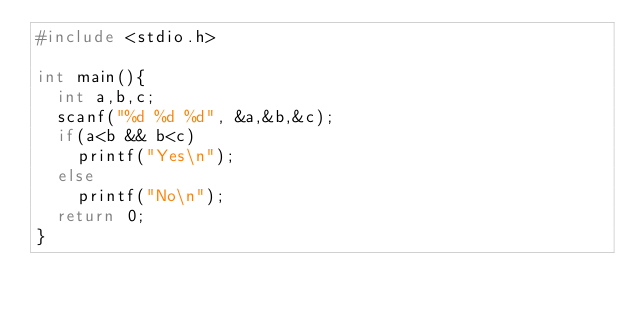<code> <loc_0><loc_0><loc_500><loc_500><_C_>#include <stdio.h>

int main(){
	int a,b,c;
	scanf("%d %d %d", &a,&b,&c);
	if(a<b && b<c)
		printf("Yes\n");
	else
		printf("No\n");
	return 0;
}</code> 